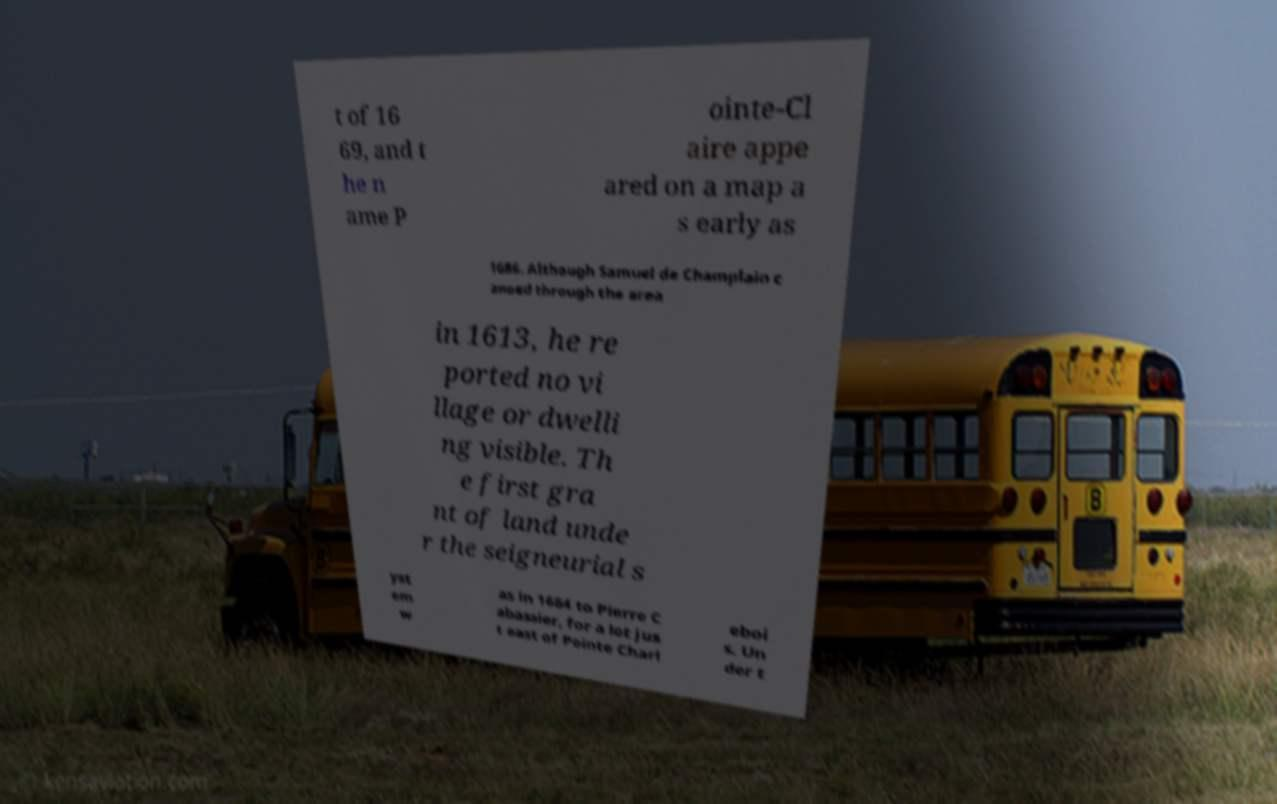Could you extract and type out the text from this image? t of 16 69, and t he n ame P ointe-Cl aire appe ared on a map a s early as 1686. Although Samuel de Champlain c anoed through the area in 1613, he re ported no vi llage or dwelli ng visible. Th e first gra nt of land unde r the seigneurial s yst em w as in 1684 to Pierre C abassier, for a lot jus t east of Pointe Charl eboi s. Un der t 